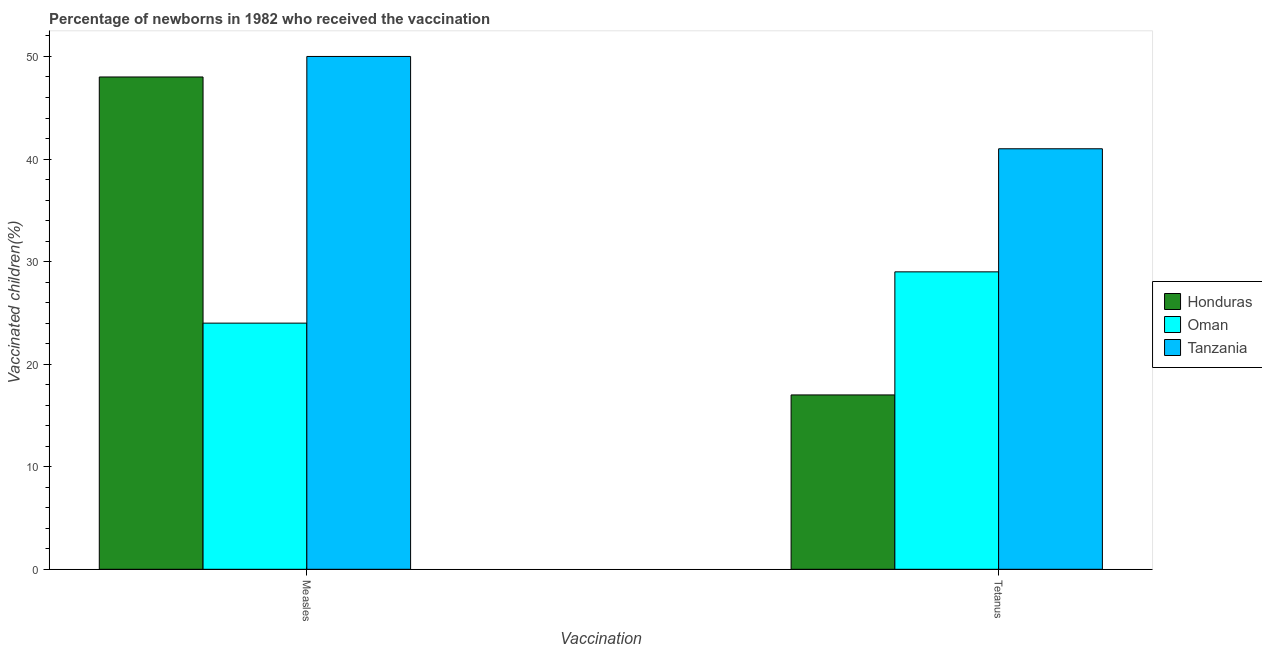Are the number of bars per tick equal to the number of legend labels?
Make the answer very short. Yes. Are the number of bars on each tick of the X-axis equal?
Give a very brief answer. Yes. How many bars are there on the 1st tick from the right?
Give a very brief answer. 3. What is the label of the 2nd group of bars from the left?
Keep it short and to the point. Tetanus. What is the percentage of newborns who received vaccination for tetanus in Oman?
Give a very brief answer. 29. Across all countries, what is the maximum percentage of newborns who received vaccination for tetanus?
Ensure brevity in your answer.  41. Across all countries, what is the minimum percentage of newborns who received vaccination for tetanus?
Your answer should be compact. 17. In which country was the percentage of newborns who received vaccination for measles maximum?
Offer a very short reply. Tanzania. In which country was the percentage of newborns who received vaccination for tetanus minimum?
Offer a terse response. Honduras. What is the total percentage of newborns who received vaccination for measles in the graph?
Provide a succinct answer. 122. What is the difference between the percentage of newborns who received vaccination for tetanus in Oman and that in Honduras?
Your answer should be very brief. 12. What is the difference between the percentage of newborns who received vaccination for measles in Honduras and the percentage of newborns who received vaccination for tetanus in Tanzania?
Keep it short and to the point. 7. What is the average percentage of newborns who received vaccination for measles per country?
Provide a succinct answer. 40.67. What is the difference between the percentage of newborns who received vaccination for tetanus and percentage of newborns who received vaccination for measles in Tanzania?
Offer a terse response. -9. What is the ratio of the percentage of newborns who received vaccination for tetanus in Honduras to that in Oman?
Make the answer very short. 0.59. In how many countries, is the percentage of newborns who received vaccination for tetanus greater than the average percentage of newborns who received vaccination for tetanus taken over all countries?
Keep it short and to the point. 1. What does the 2nd bar from the left in Tetanus represents?
Your answer should be very brief. Oman. What does the 1st bar from the right in Tetanus represents?
Provide a short and direct response. Tanzania. Are all the bars in the graph horizontal?
Offer a very short reply. No. How many countries are there in the graph?
Provide a short and direct response. 3. What is the difference between two consecutive major ticks on the Y-axis?
Give a very brief answer. 10. Are the values on the major ticks of Y-axis written in scientific E-notation?
Offer a terse response. No. Does the graph contain grids?
Your response must be concise. No. Where does the legend appear in the graph?
Offer a terse response. Center right. How many legend labels are there?
Provide a succinct answer. 3. What is the title of the graph?
Make the answer very short. Percentage of newborns in 1982 who received the vaccination. What is the label or title of the X-axis?
Your answer should be very brief. Vaccination. What is the label or title of the Y-axis?
Your answer should be very brief. Vaccinated children(%)
. What is the Vaccinated children(%)
 in Honduras in Measles?
Your response must be concise. 48. What is the Vaccinated children(%)
 in Tanzania in Tetanus?
Offer a very short reply. 41. Across all Vaccination, what is the maximum Vaccinated children(%)
 of Honduras?
Keep it short and to the point. 48. Across all Vaccination, what is the maximum Vaccinated children(%)
 in Oman?
Your answer should be compact. 29. Across all Vaccination, what is the minimum Vaccinated children(%)
 in Honduras?
Your response must be concise. 17. Across all Vaccination, what is the minimum Vaccinated children(%)
 of Tanzania?
Your response must be concise. 41. What is the total Vaccinated children(%)
 of Honduras in the graph?
Keep it short and to the point. 65. What is the total Vaccinated children(%)
 in Oman in the graph?
Make the answer very short. 53. What is the total Vaccinated children(%)
 in Tanzania in the graph?
Make the answer very short. 91. What is the difference between the Vaccinated children(%)
 in Honduras in Measles and that in Tetanus?
Your answer should be very brief. 31. What is the difference between the Vaccinated children(%)
 of Oman in Measles and that in Tetanus?
Provide a succinct answer. -5. What is the difference between the Vaccinated children(%)
 of Tanzania in Measles and that in Tetanus?
Provide a short and direct response. 9. What is the difference between the Vaccinated children(%)
 of Honduras in Measles and the Vaccinated children(%)
 of Oman in Tetanus?
Ensure brevity in your answer.  19. What is the difference between the Vaccinated children(%)
 of Oman in Measles and the Vaccinated children(%)
 of Tanzania in Tetanus?
Give a very brief answer. -17. What is the average Vaccinated children(%)
 of Honduras per Vaccination?
Your response must be concise. 32.5. What is the average Vaccinated children(%)
 in Tanzania per Vaccination?
Your response must be concise. 45.5. What is the difference between the Vaccinated children(%)
 of Oman and Vaccinated children(%)
 of Tanzania in Measles?
Ensure brevity in your answer.  -26. What is the difference between the Vaccinated children(%)
 in Honduras and Vaccinated children(%)
 in Oman in Tetanus?
Your answer should be compact. -12. What is the difference between the Vaccinated children(%)
 of Honduras and Vaccinated children(%)
 of Tanzania in Tetanus?
Your answer should be very brief. -24. What is the ratio of the Vaccinated children(%)
 of Honduras in Measles to that in Tetanus?
Ensure brevity in your answer.  2.82. What is the ratio of the Vaccinated children(%)
 of Oman in Measles to that in Tetanus?
Offer a very short reply. 0.83. What is the ratio of the Vaccinated children(%)
 in Tanzania in Measles to that in Tetanus?
Make the answer very short. 1.22. What is the difference between the highest and the second highest Vaccinated children(%)
 in Honduras?
Provide a short and direct response. 31. 